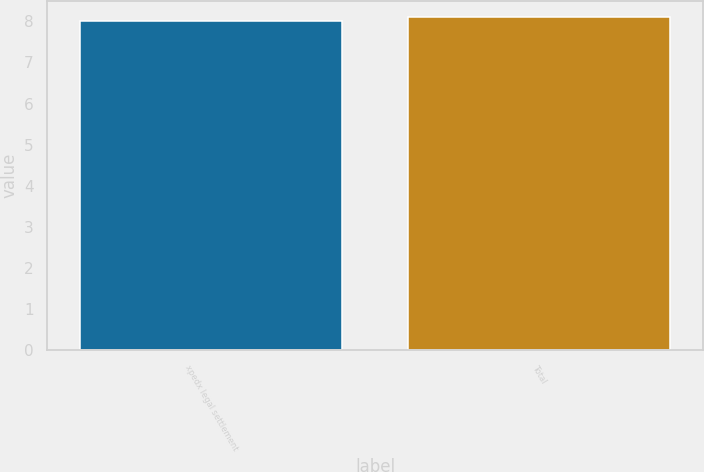Convert chart to OTSL. <chart><loc_0><loc_0><loc_500><loc_500><bar_chart><fcel>xpedx legal settlement<fcel>Total<nl><fcel>8<fcel>8.1<nl></chart> 